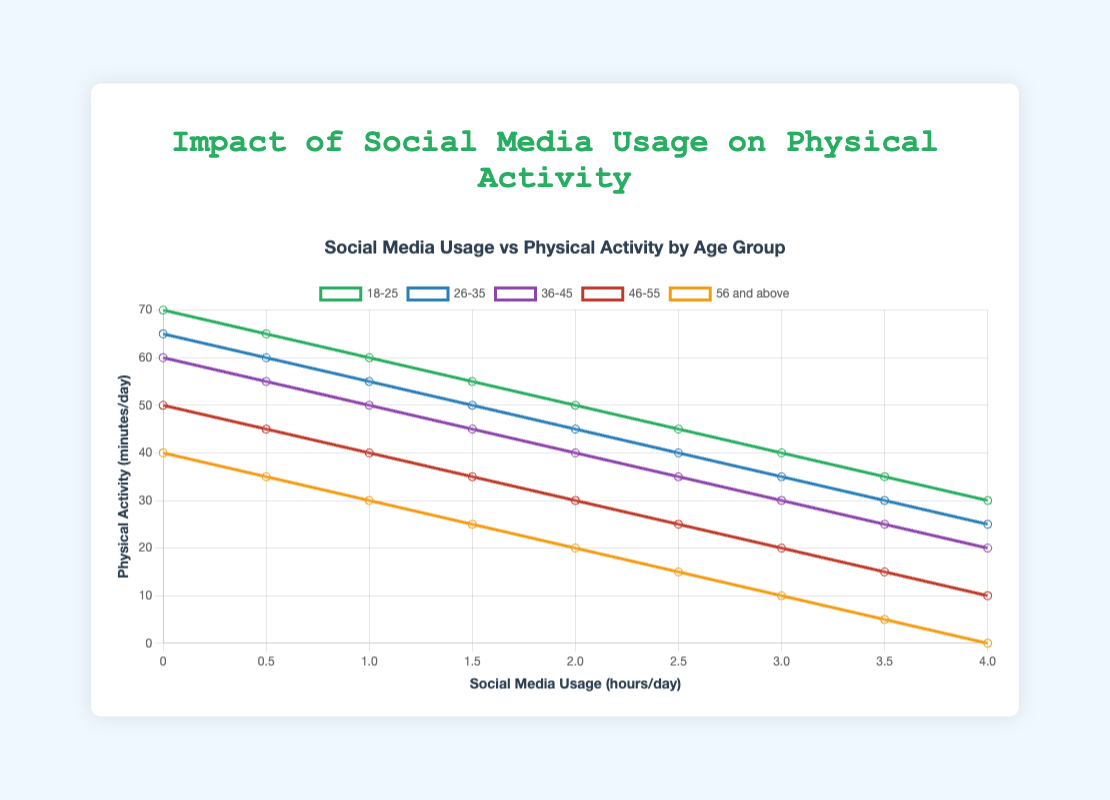What is the average physical activity for the 18-25 age group when social media usage is more than 2 hours per day? Sum physical activity minutes for social media usage of 2.5, 3, 3.5, and 4 hours per day: (45 + 40 + 35 + 30) = 150. There are 4 data points, so the average is 150/4 = 37.5
Answer: 37.5 Which age group exhibits the steepest decline in physical activity with increasing social media usage? Identify the age group with the largest difference in physical activity minutes from 0 to 4 hours of social media usage. Calculate the difference for each group: 18-25 (70-30=40), 26-35 (65-25=40), 36-45 (60-20=40), 46-55 (50-10=40), 56 and above (40-0=40). Each group declines by 40 minutes, indicating they all have the same decline rate.
Answer: All groups (equal) At 1 hour of social media usage per day, do individuals aged 36-45 engage in more or less physical activity compared to those aged 46-55? Compare the physical activity minutes for 1 hour of social media usage in the two specified age groups: 36-45 age group (50 mins) vs. 46-55 age group (40 mins).
Answer: More Which age group, on average, spends the least time in physical activity across all levels of social media usage? Calculate average physical activity for each group across all social media usage hours and identify the smallest: 18-25 (average 47.22), 26-35 (average 42.78), 36-45 (average 37.78), 46-55 (average 31.67), 56 and above (average 20). The 56 and above group has the lowest average.
Answer: 56 and above What is the difference in physical activity between the 18-25 age group and the 56 and above age group at 2 hours of social media usage per day? Compare physical activity minutes at 2 hours for both groups: 18-25 (50 mins) vs. 56 and above (20 mins). The difference is 50 - 20 = 30 minutes.
Answer: 30 Which age group shows the same initial physical activity at 0 hours of social media usage, and what is that activity level? Compare the physical activity at 0 hours for each age group: 18-25 (70), 26-35 (65), 36-45 (60), 46-55 (50), 56 and above (40). There is no age group with the same physical activity level at 0 hours, all are different.
Answer: None For the age group 26-35, what is the total reduction in physical activity minutes from 0 hours to 4 hours of social media usage per day? Calculate the difference between physical activity minutes at 0 hours and 4 hours for the group: 65 minutes at 0 hours minus 25 minutes at 4 hours equals a reduction of 65 - 25 = 40 minutes.
Answer: 40 Which age group maintains at least 30 minutes of physical activity until reaching 3 hours of social media usage per day? Check physical activity minutes for each age group up to 3 hours: 18-25 (yes: 45 at 2.5), 26-35 (yes: 35 at 3), 36-45 (yes: 30 at 3), 46-55 (no: <30 at 2.5), 56 and above (no: <30 at 1.5).
Answer: 18-25, 26-35, 36-45 